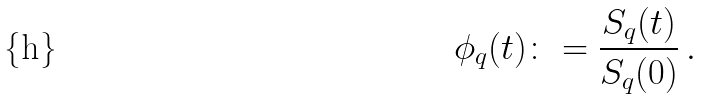Convert formula to latex. <formula><loc_0><loc_0><loc_500><loc_500>\phi _ { q } ( t ) \colon = \frac { S _ { q } ( t ) } { S _ { q } ( 0 ) } \, .</formula> 